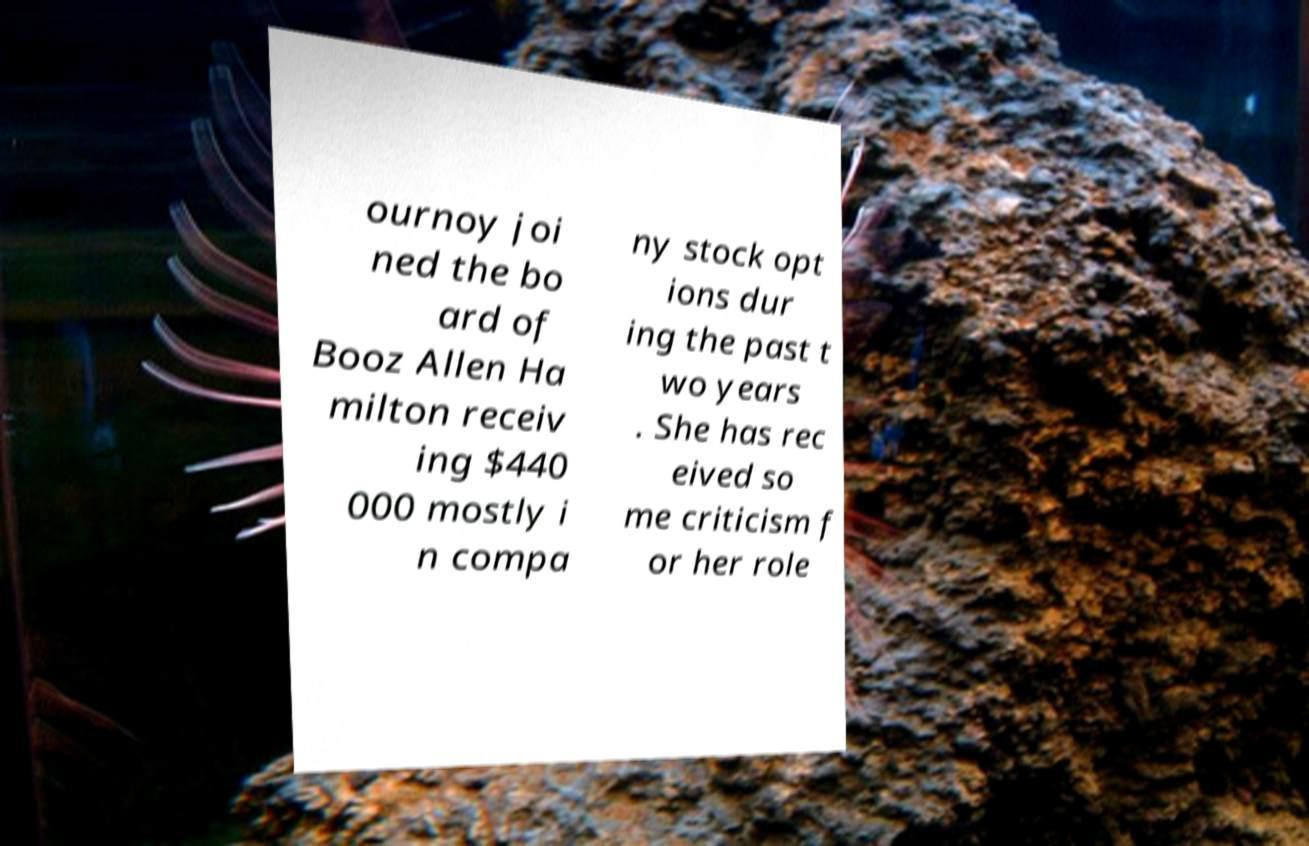Can you read and provide the text displayed in the image?This photo seems to have some interesting text. Can you extract and type it out for me? ournoy joi ned the bo ard of Booz Allen Ha milton receiv ing $440 000 mostly i n compa ny stock opt ions dur ing the past t wo years . She has rec eived so me criticism f or her role 